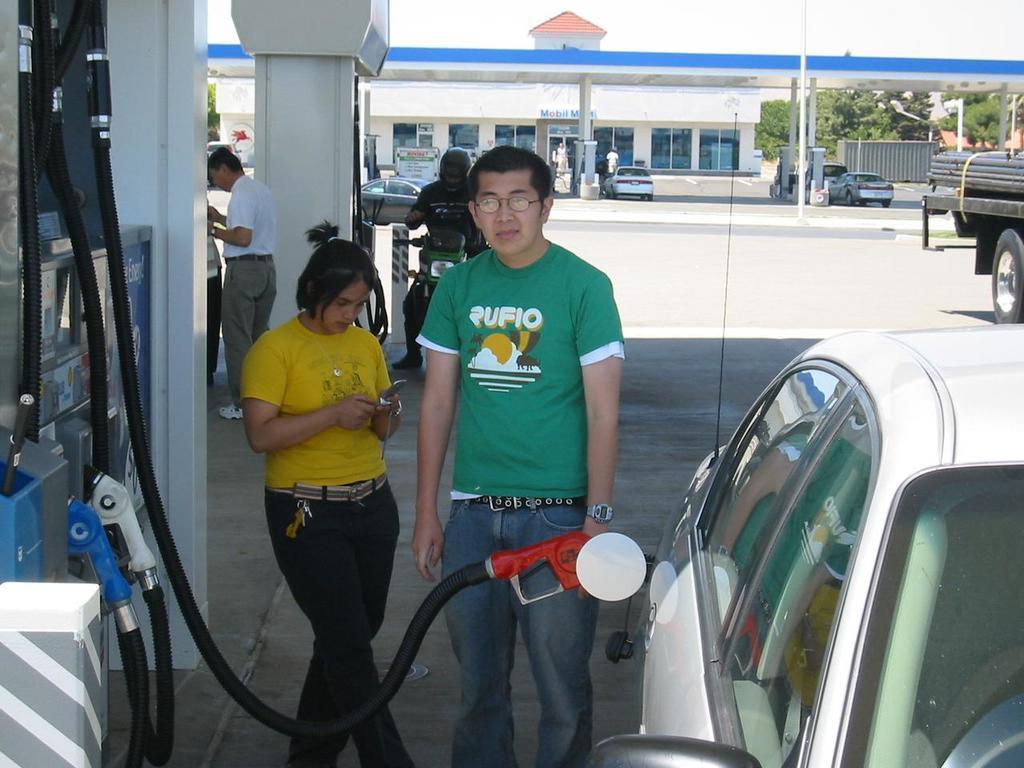Can you describe this image briefly? In this image I can see petrol pumps. Here I can see people among them this man is holding an object in the hand. In the background I can see vehicles, trees, a building and the sky. 